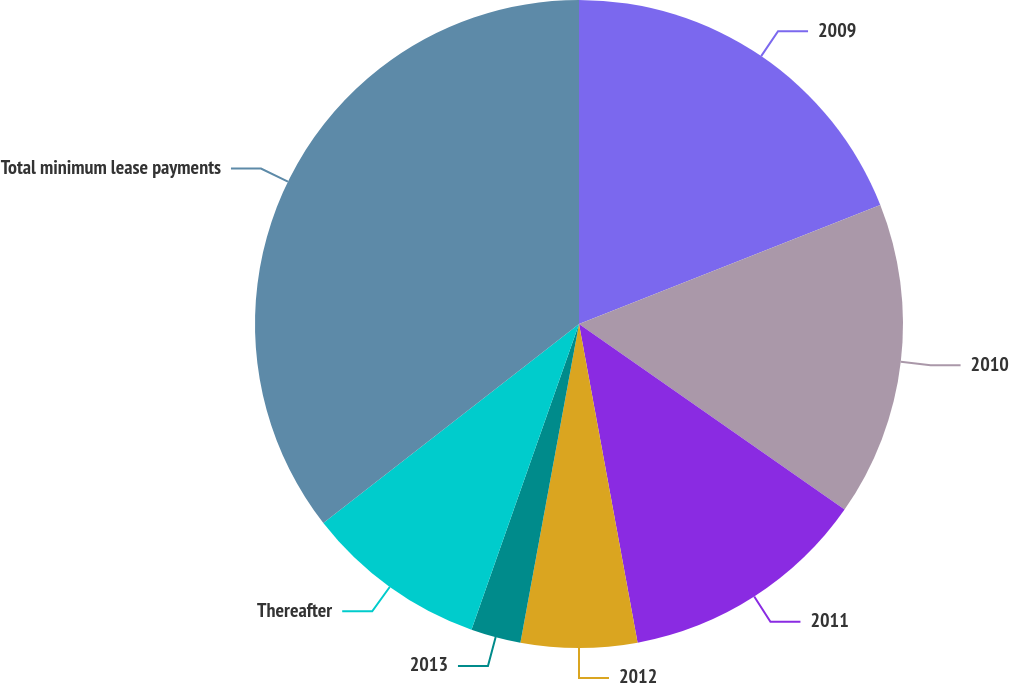Convert chart. <chart><loc_0><loc_0><loc_500><loc_500><pie_chart><fcel>2009<fcel>2010<fcel>2011<fcel>2012<fcel>2013<fcel>Thereafter<fcel>Total minimum lease payments<nl><fcel>19.01%<fcel>15.7%<fcel>12.4%<fcel>5.79%<fcel>2.49%<fcel>9.09%<fcel>35.53%<nl></chart> 